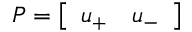<formula> <loc_0><loc_0><loc_500><loc_500>P = \left [ \begin{array} { l l } { u _ { + } } & { u _ { - } } \end{array} \right ]</formula> 